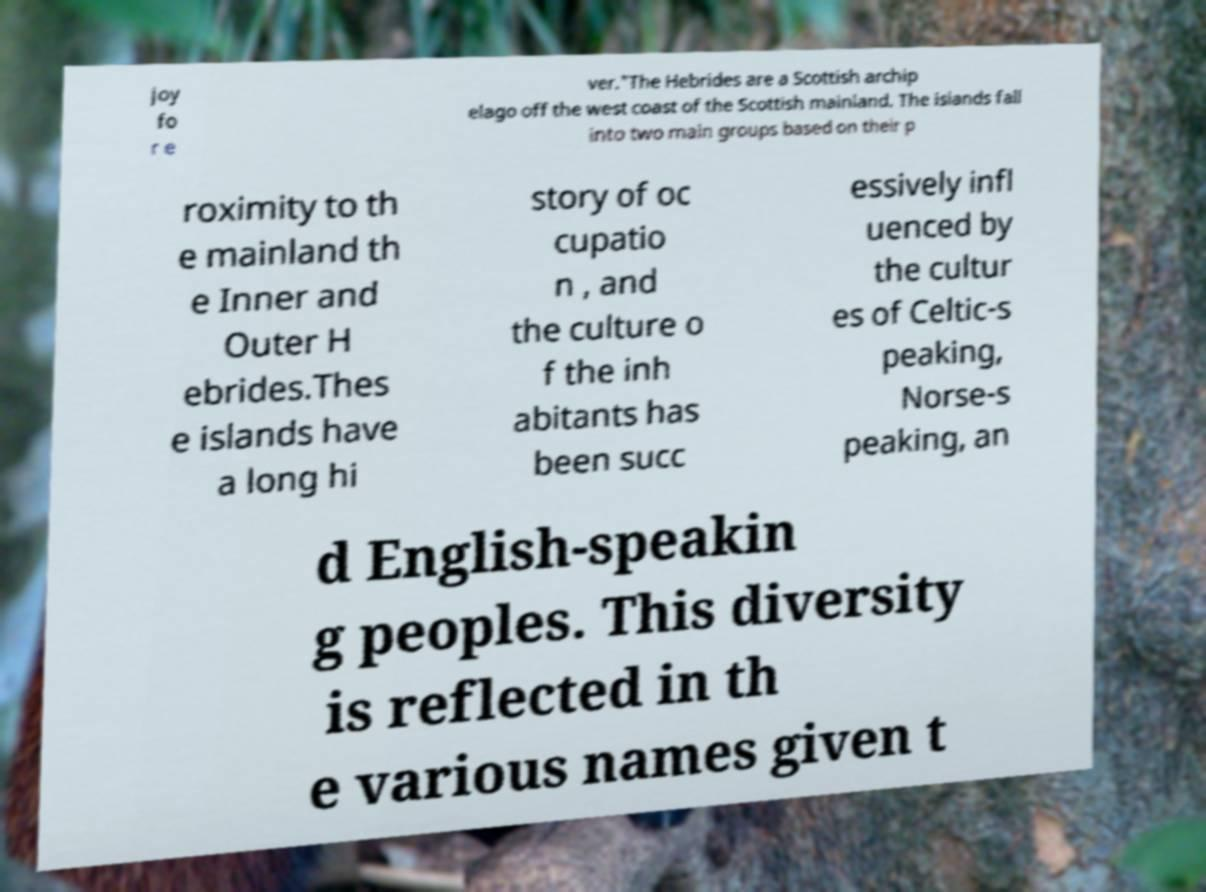Can you read and provide the text displayed in the image?This photo seems to have some interesting text. Can you extract and type it out for me? joy fo r e ver."The Hebrides are a Scottish archip elago off the west coast of the Scottish mainland. The islands fall into two main groups based on their p roximity to th e mainland th e Inner and Outer H ebrides.Thes e islands have a long hi story of oc cupatio n , and the culture o f the inh abitants has been succ essively infl uenced by the cultur es of Celtic-s peaking, Norse-s peaking, an d English-speakin g peoples. This diversity is reflected in th e various names given t 